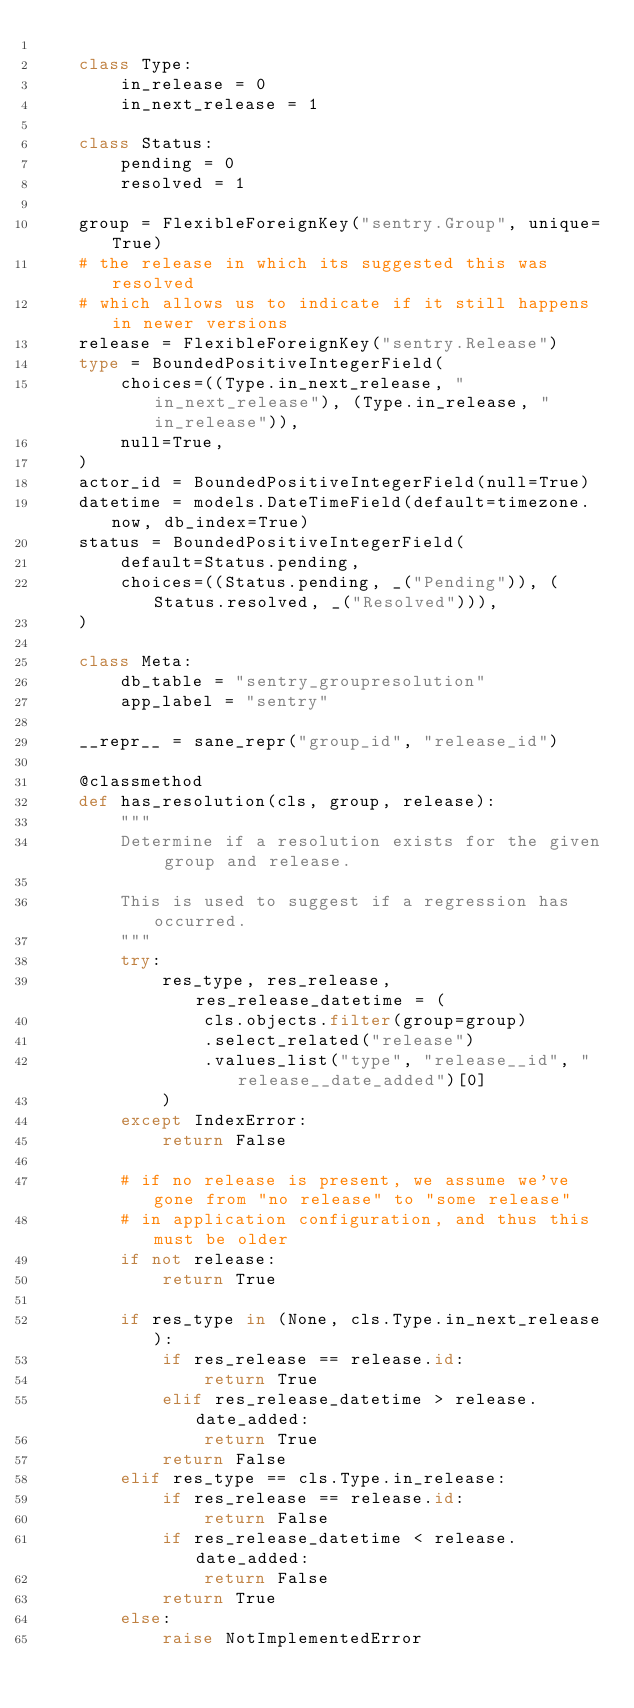Convert code to text. <code><loc_0><loc_0><loc_500><loc_500><_Python_>
    class Type:
        in_release = 0
        in_next_release = 1

    class Status:
        pending = 0
        resolved = 1

    group = FlexibleForeignKey("sentry.Group", unique=True)
    # the release in which its suggested this was resolved
    # which allows us to indicate if it still happens in newer versions
    release = FlexibleForeignKey("sentry.Release")
    type = BoundedPositiveIntegerField(
        choices=((Type.in_next_release, "in_next_release"), (Type.in_release, "in_release")),
        null=True,
    )
    actor_id = BoundedPositiveIntegerField(null=True)
    datetime = models.DateTimeField(default=timezone.now, db_index=True)
    status = BoundedPositiveIntegerField(
        default=Status.pending,
        choices=((Status.pending, _("Pending")), (Status.resolved, _("Resolved"))),
    )

    class Meta:
        db_table = "sentry_groupresolution"
        app_label = "sentry"

    __repr__ = sane_repr("group_id", "release_id")

    @classmethod
    def has_resolution(cls, group, release):
        """
        Determine if a resolution exists for the given group and release.

        This is used to suggest if a regression has occurred.
        """
        try:
            res_type, res_release, res_release_datetime = (
                cls.objects.filter(group=group)
                .select_related("release")
                .values_list("type", "release__id", "release__date_added")[0]
            )
        except IndexError:
            return False

        # if no release is present, we assume we've gone from "no release" to "some release"
        # in application configuration, and thus this must be older
        if not release:
            return True

        if res_type in (None, cls.Type.in_next_release):
            if res_release == release.id:
                return True
            elif res_release_datetime > release.date_added:
                return True
            return False
        elif res_type == cls.Type.in_release:
            if res_release == release.id:
                return False
            if res_release_datetime < release.date_added:
                return False
            return True
        else:
            raise NotImplementedError
</code> 